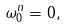Convert formula to latex. <formula><loc_0><loc_0><loc_500><loc_500>\omega _ { 0 } ^ { n } = 0 ,</formula> 